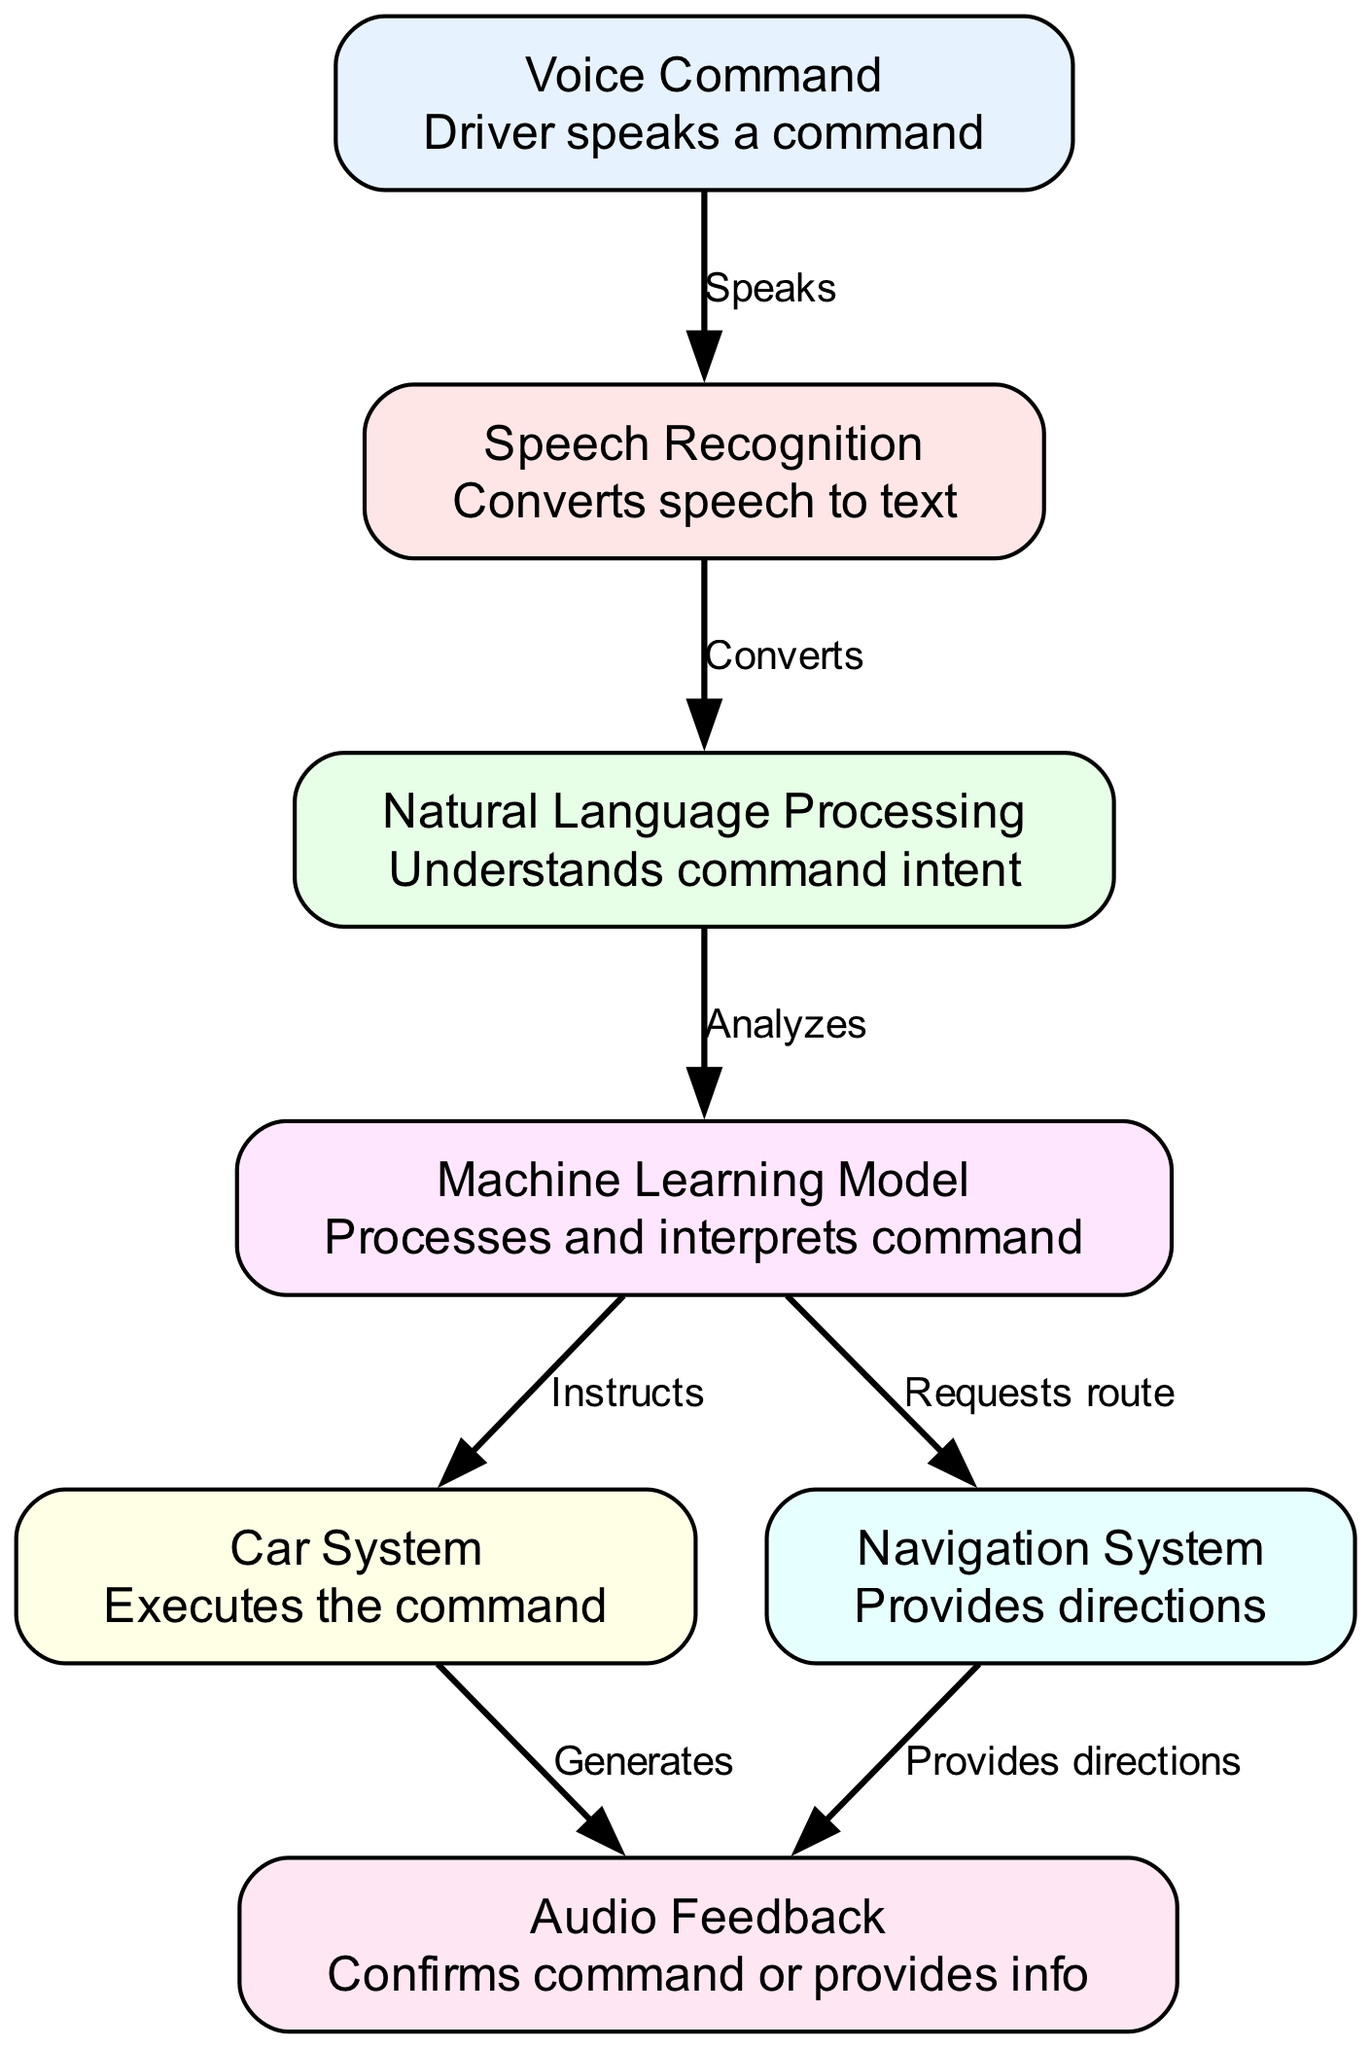What is the first step initiated by the driver? The driver begins the process by speaking a command, which is depicted in the diagram as the starting node labeled "Voice Command." This is the action that triggers the subsequent steps in the machine learning process.
Answer: Voice Command How many nodes are there in the diagram? To determine the total number of nodes, we can count all the distinct elements that represent processes or components in the diagram. There are seven nodes: "Voice Command," "Speech Recognition," "Natural Language Processing," "Machine Learning Model," "Car System," "Navigation System," and "Audio Feedback."
Answer: Seven What action follows speech recognition? After "Speech Recognition," the next action that occurs is the analysis performed by "Natural Language Processing." This is shown in the diagram where an arrow connects these two nodes, indicating the flow of information from one to the next.
Answer: Analyzes What does the machine learning model do after processing the command? Following the processing of the command, the "Machine Learning Model" sends instructions to both "Car System" and "Navigation System." This is represented by the outgoing edges leading from the "Machine Learning Model" to these two nodes, demonstrating its role in both execution and route request.
Answer: Instructs and Requests route What type of feedback is provided after executing a command? After the "Car System" executes the command, it generates "Audio Feedback." Additionally, the "Navigation System" also provides directions that serve as feedback to the driver. This dual feedback mechanism highlights how the system communicates results to the user.
Answer: Audio Feedback How does the navigation system confirm the route? The "Navigation System" confirms the route by providing directions as feedback. The connection from "Navigation" to "Audio Feedback" in the diagram indicates that it has a role in validating and communicating the route information to the driver.
Answer: Provides directions What is the role of the natural language processing node? The role of the "Natural Language Processing" node is to analyze the command's intent, which is crucial for understanding what the driver wants based on their spoken input. This interpretation guides further actions in the diagram.
Answer: Understands command intent 